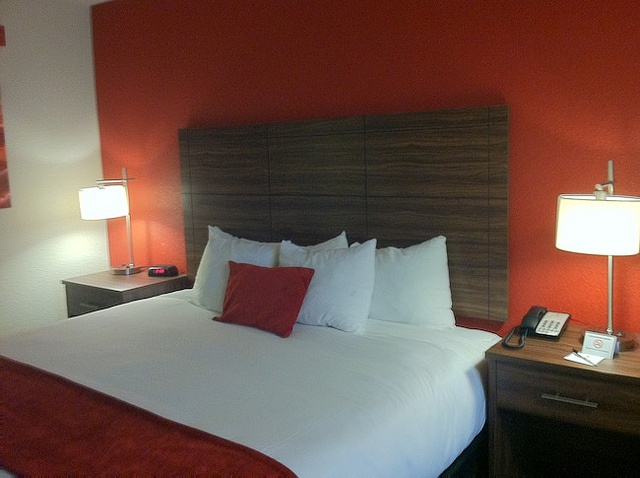Describe the objects in this image and their specific colors. I can see bed in gray, darkgray, black, and maroon tones and clock in gray, black, maroon, and brown tones in this image. 